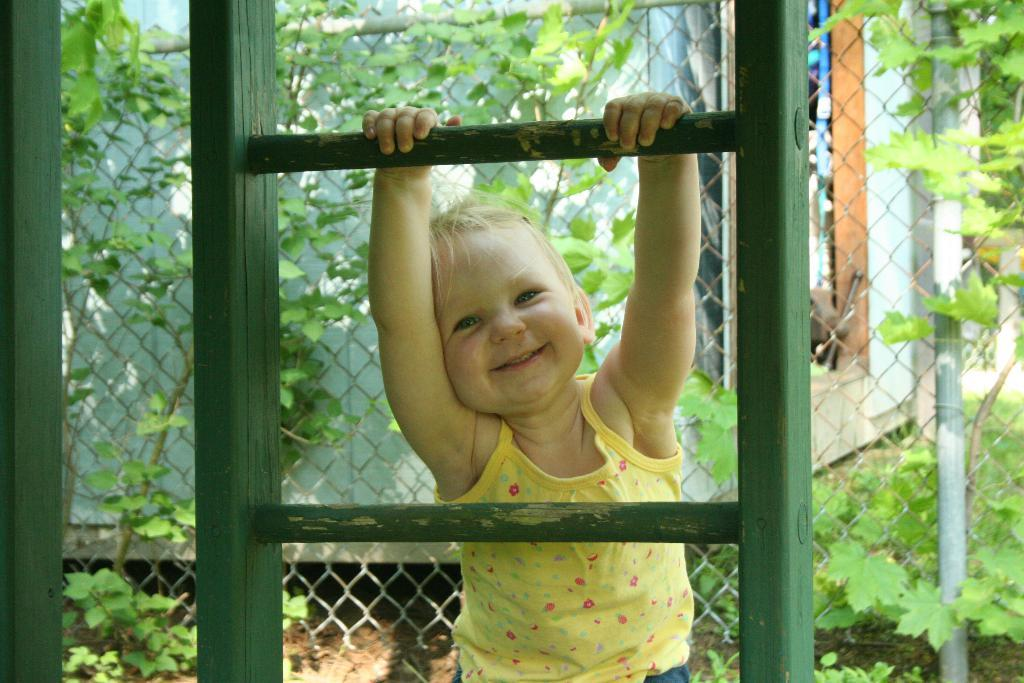What can be seen in the image that provides a view of the outdoors? There is a window in the image. What is the child in the image doing? The child is holding a window road and smiling. What type of background can be seen in the image? There is a fencing wall with plants and a house wall in the background. What type of straw is the child using to respect the brick wall in the image? There is no straw or brick wall present in the image. The child is holding a window road and smiling, and there is a fencing wall with plants and a house wall in the background. 